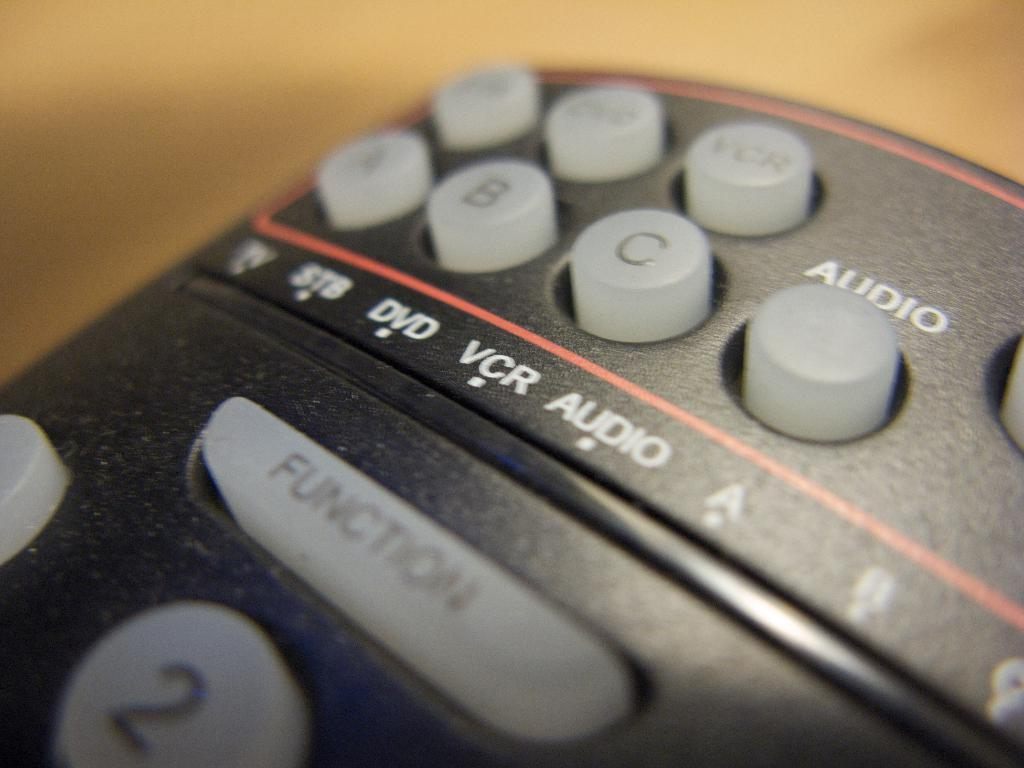<image>
Share a concise interpretation of the image provided. A remote control contains settings for functions such as VCR, DVD, audio and more. 